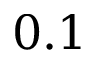Convert formula to latex. <formula><loc_0><loc_0><loc_500><loc_500>0 . 1</formula> 